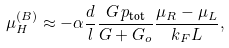Convert formula to latex. <formula><loc_0><loc_0><loc_500><loc_500>\mu _ { H } ^ { ( B ) } \approx - \alpha \frac { d } { l } \frac { G \, p _ { \text {tot} } } { G + G _ { o } } \frac { \mu _ { R } - \mu _ { L } } { k _ { F } L } ,</formula> 